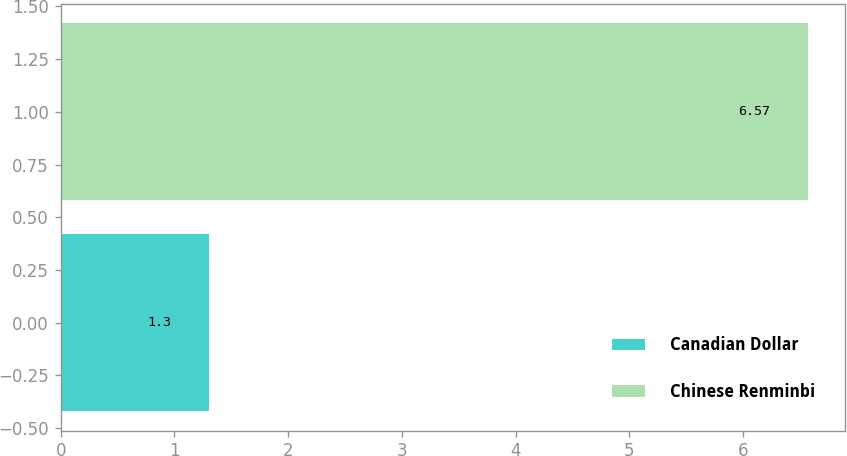Convert chart. <chart><loc_0><loc_0><loc_500><loc_500><bar_chart><fcel>Canadian Dollar<fcel>Chinese Renminbi<nl><fcel>1.3<fcel>6.57<nl></chart> 